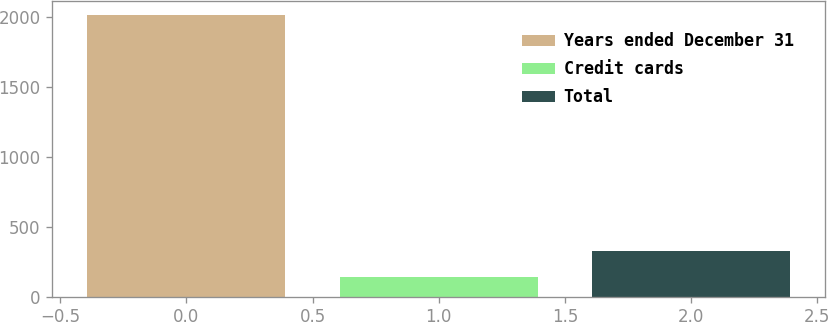Convert chart. <chart><loc_0><loc_0><loc_500><loc_500><bar_chart><fcel>Years ended December 31<fcel>Credit cards<fcel>Total<nl><fcel>2014<fcel>140<fcel>327.4<nl></chart> 